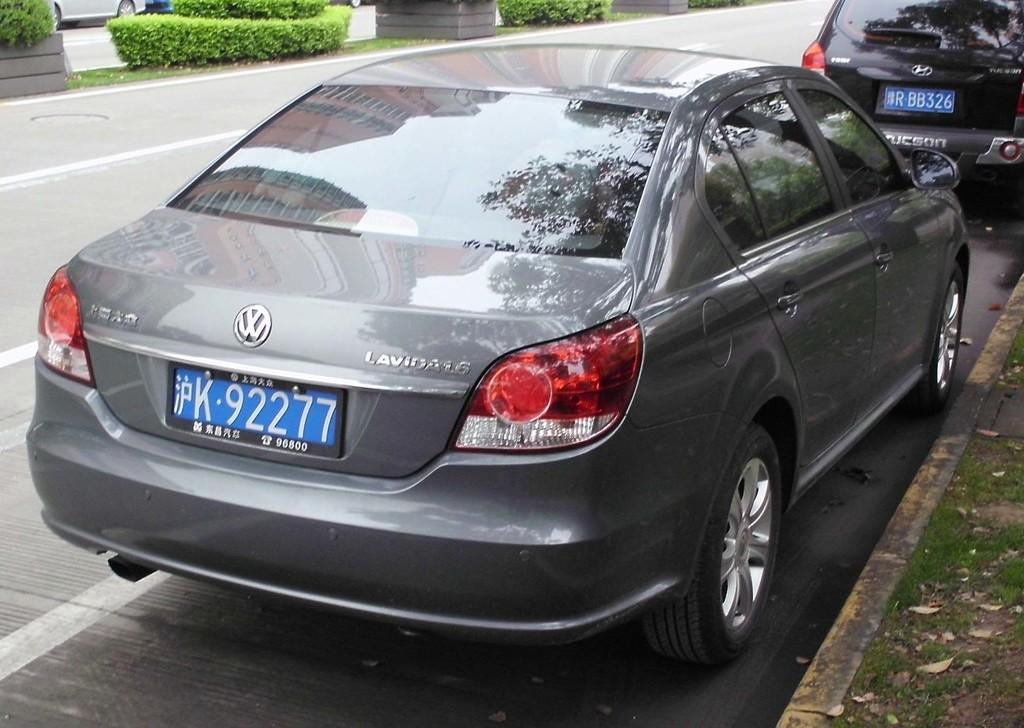<image>
Describe the image concisely. A VW Lavida has a blue license plate K 92277. 